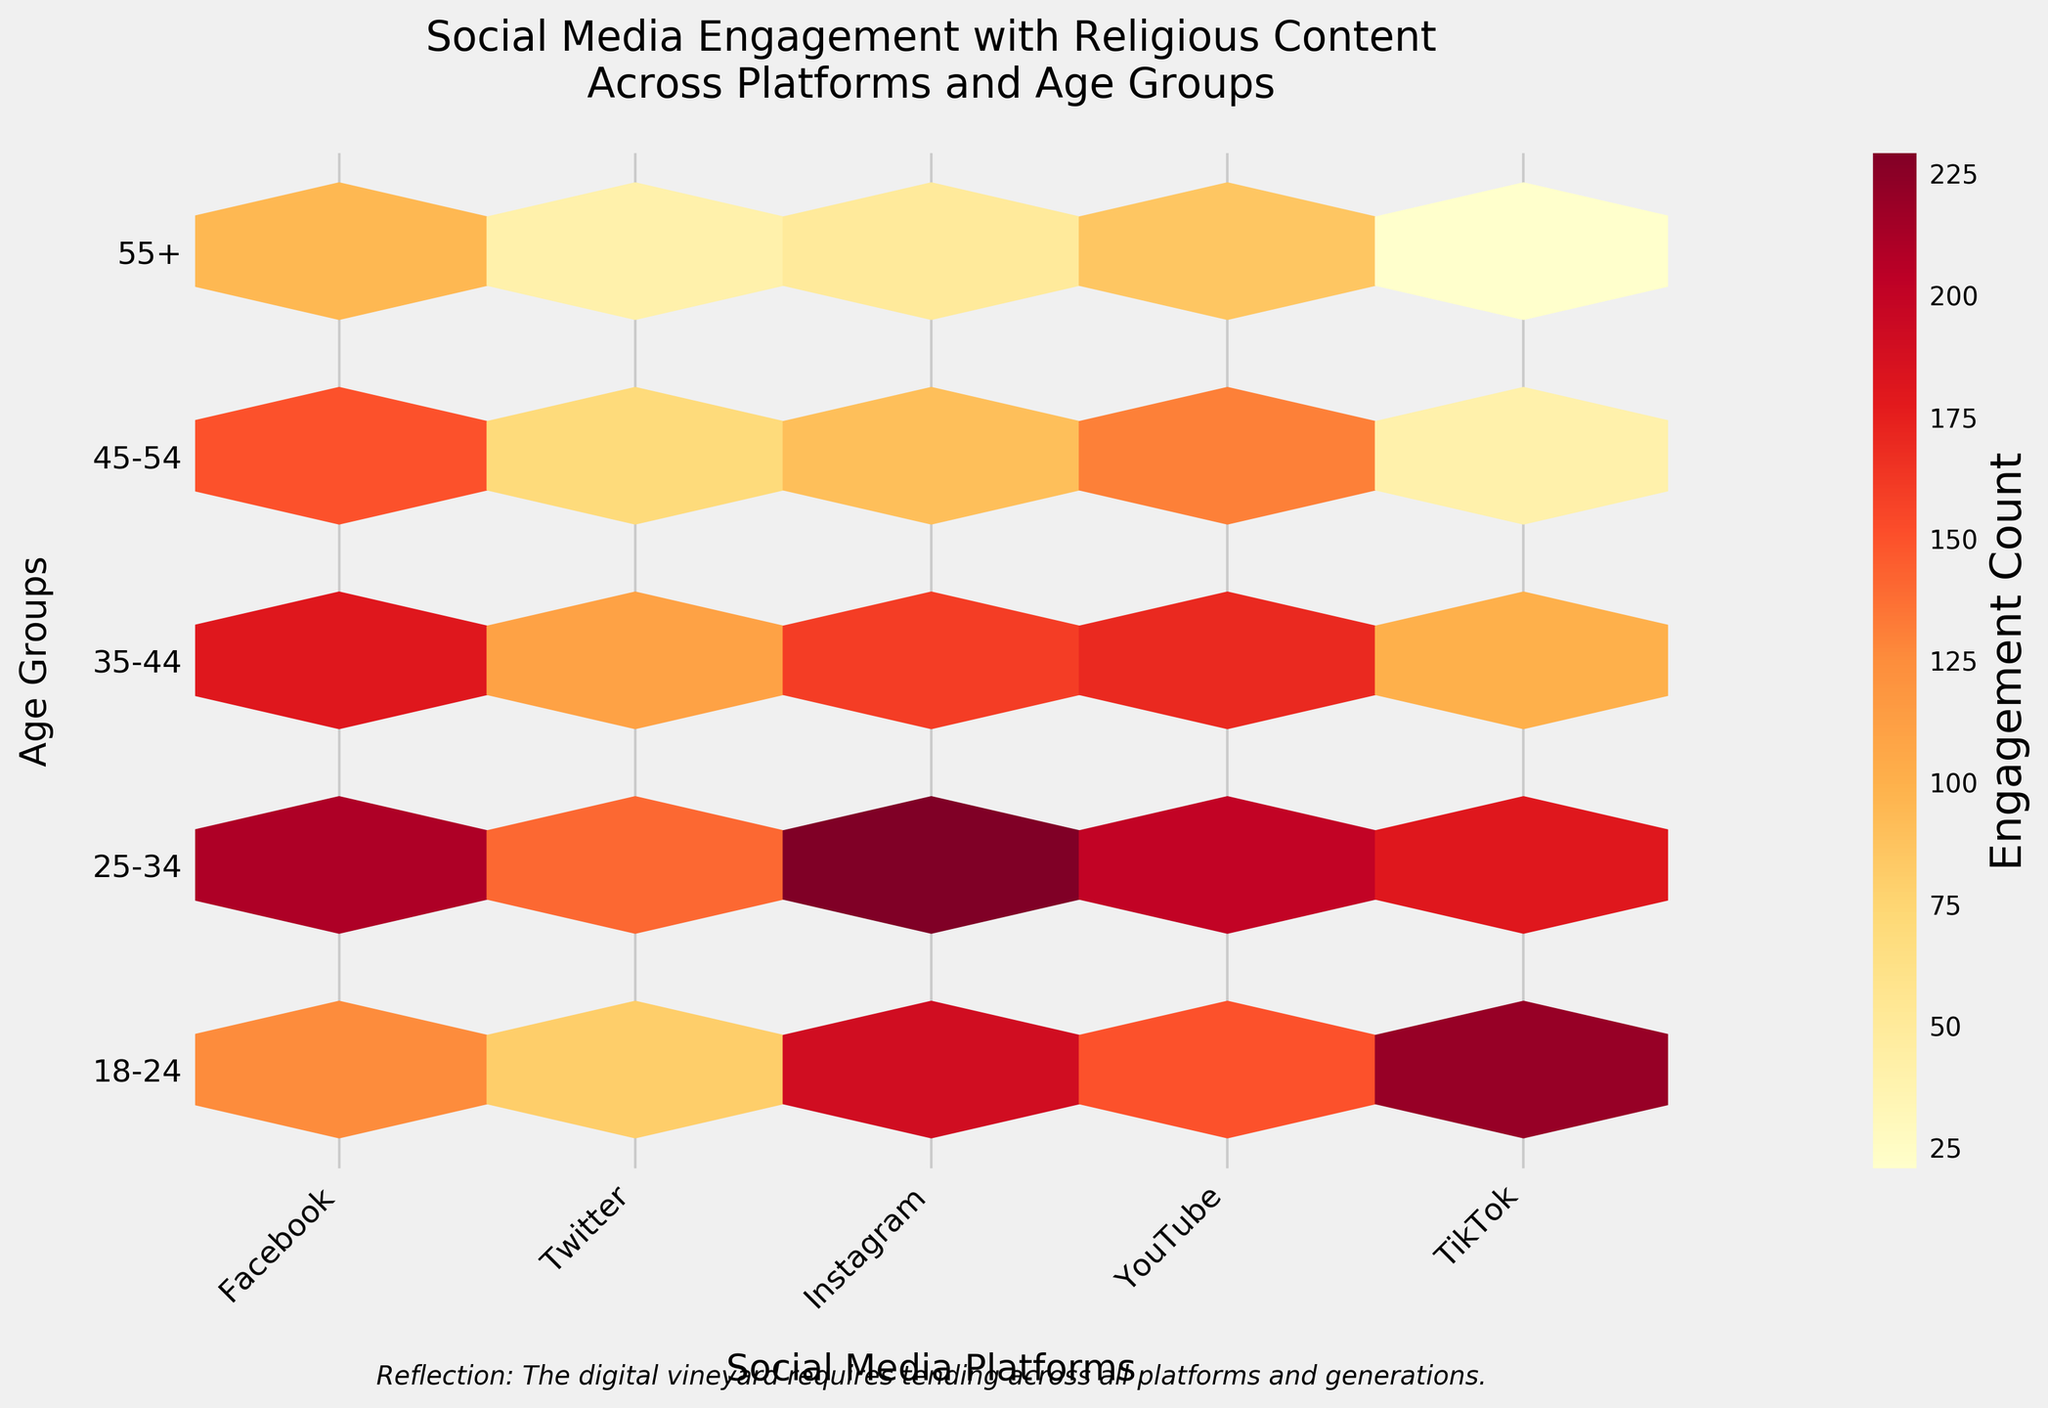what is the title of the figure? The title of the figure is written at the top and summarises the content of the plot. Refer to the text at the top of the plot.
Answer: "Social Media Engagement with Religious Content Across Platforms and Age Groups" What is the color representing the highest engagement count? The color gradient in the plot represents different levels of engagement. The hexbin plot uses a color map, and the darkest color represents the highest engagement count. Look at the legend indicating 'Engagement Count'.
Answer: dark red Which social media platform has the highest engagement for the 18-24 age group? To find the highest engagement for the 18-24 age group, refer to the row labeled '18-24' and identify the darkest hexbin among the platforms.
Answer: TikTok Compare the engagement for the 45-54 age group between Facebook and Twitter. Which one is higher? Identify the hexagon at the position where the row '45-54' intersects with the columns 'Facebook' and 'Twitter'. Compare the color intensity for the two platforms.
Answer: Facebook What conclusion can you draw about the social media platform engagement from TikTok versus YouTube for users aged 55+? Locate the hexagons where the '55+' row intersects with TikTok and YouTube columns. Compare the color intensity to determine which platform has higher engagement.
Answer: YouTube has higher engagement than TikTok for the 55+ demographic In the 25-34 age group, which social media platform has the lowest engagement? Examine the '25-34' row and identify the platform with the lightest colored hexagon to determine the lowest engagement.
Answer: Twitter What is the sum of engagement counts for the 18-24 age group across all platforms? Add the engagement counts for the '18-24' row across each platform from the dataset: 125 (Facebook) + 80 (Twitter) + 190 (Instagram) + 150 (YouTube) + 220 (TikTok).
Answer: 765 How does the distribution of engagement across age groups on Instagram compare to Facebook? Compare the color intensities in the hexagons for each age group between Instagram and Facebook to determine the distribution pattern.
Answer: Instagram has higher engagement in younger age groups compared to Facebook, which has more balanced engagement across different age groups Which age group shows the greatest variance in engagement across different platforms? Analyze the color variations within each row. The greatest variance will be where the colors range from very light to very dark.
Answer: 18-24 age group Is there a noticeable trend in engagement levels for older age groups (45-54 and 55+) across all platforms? Observe the color intensity in the rows '45-54' and '55+' across all platforms. A trend can be identified by looking at variations and comparing the colors.
Answer: Engagement generally decreases for older age groups across all platforms 